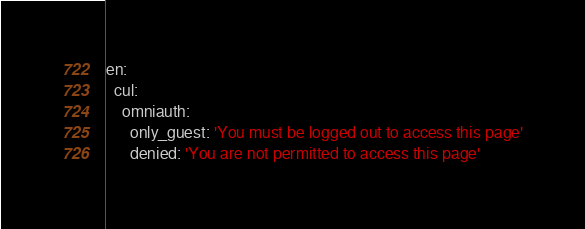<code> <loc_0><loc_0><loc_500><loc_500><_YAML_>en:
  cul:
    omniauth:
      only_guest: 'You must be logged out to access this page'
      denied: 'You are not permitted to access this page'</code> 